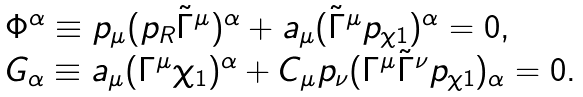Convert formula to latex. <formula><loc_0><loc_0><loc_500><loc_500>\begin{array} { l } \Phi ^ { \alpha } \equiv p _ { \mu } ( p _ { R } \tilde { \Gamma } ^ { \mu } ) ^ { \alpha } + \L a _ { \mu } ( \tilde { \Gamma } ^ { \mu } p _ { \chi 1 } ) ^ { \alpha } = 0 , \\ G _ { \alpha } \equiv \L a _ { \mu } ( \Gamma ^ { \mu } \chi _ { 1 } ) ^ { \alpha } + C _ { \mu } p _ { \nu } ( \Gamma ^ { \mu } \tilde { \Gamma } ^ { \nu } p _ { \chi 1 } ) _ { \alpha } = 0 . \end{array}</formula> 